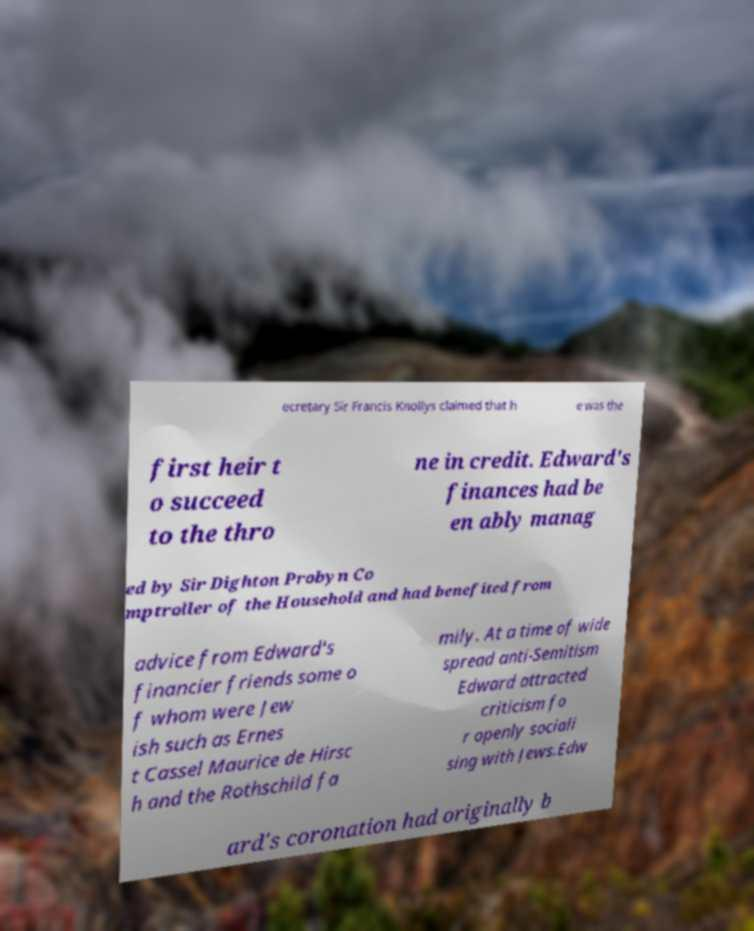Can you accurately transcribe the text from the provided image for me? ecretary Sir Francis Knollys claimed that h e was the first heir t o succeed to the thro ne in credit. Edward's finances had be en ably manag ed by Sir Dighton Probyn Co mptroller of the Household and had benefited from advice from Edward's financier friends some o f whom were Jew ish such as Ernes t Cassel Maurice de Hirsc h and the Rothschild fa mily. At a time of wide spread anti-Semitism Edward attracted criticism fo r openly sociali sing with Jews.Edw ard's coronation had originally b 